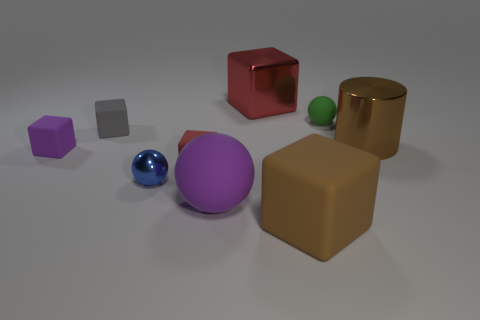What is the size of the object that is the same color as the large shiny cube?
Offer a very short reply. Small. How many big purple matte things are the same shape as the green thing?
Give a very brief answer. 1. There is a blue sphere that is to the left of the shiny thing on the right side of the red metal cube; what number of small objects are in front of it?
Keep it short and to the point. 0. How many blocks are on the right side of the small gray object and behind the big purple rubber object?
Give a very brief answer. 2. There is a tiny matte thing that is the same color as the big ball; what shape is it?
Make the answer very short. Cube. Are there any other things that are made of the same material as the brown cube?
Keep it short and to the point. Yes. Is the small gray object made of the same material as the green sphere?
Make the answer very short. Yes. What is the shape of the large metal thing that is in front of the tiny rubber thing that is to the right of the purple matte object on the right side of the gray matte block?
Provide a short and direct response. Cylinder. Is the number of tiny red matte cubes right of the big red metal cube less than the number of tiny purple rubber objects that are left of the tiny matte sphere?
Your response must be concise. Yes. There is a large matte thing that is on the right side of the rubber sphere that is in front of the tiny rubber sphere; what is its shape?
Your response must be concise. Cube. 